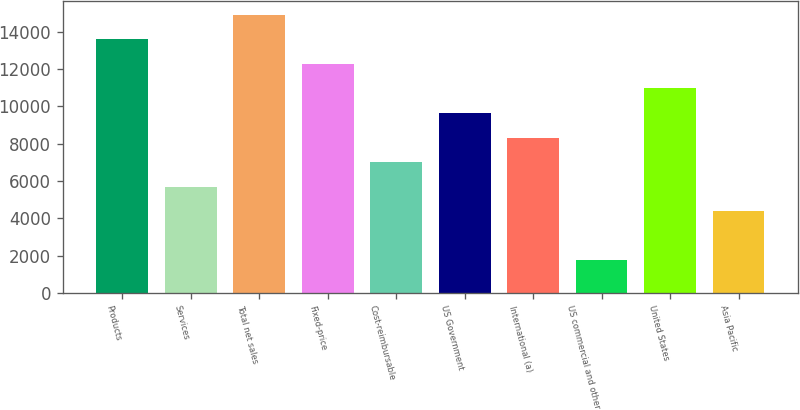Convert chart to OTSL. <chart><loc_0><loc_0><loc_500><loc_500><bar_chart><fcel>Products<fcel>Services<fcel>Total net sales<fcel>Fixed-price<fcel>Cost-reimbursable<fcel>US Government<fcel>International (a)<fcel>US commercial and other<fcel>United States<fcel>Asia Pacific<nl><fcel>13595<fcel>5695.4<fcel>14911.6<fcel>12278.4<fcel>7012<fcel>9645.2<fcel>8328.6<fcel>1745.6<fcel>10961.8<fcel>4378.8<nl></chart> 